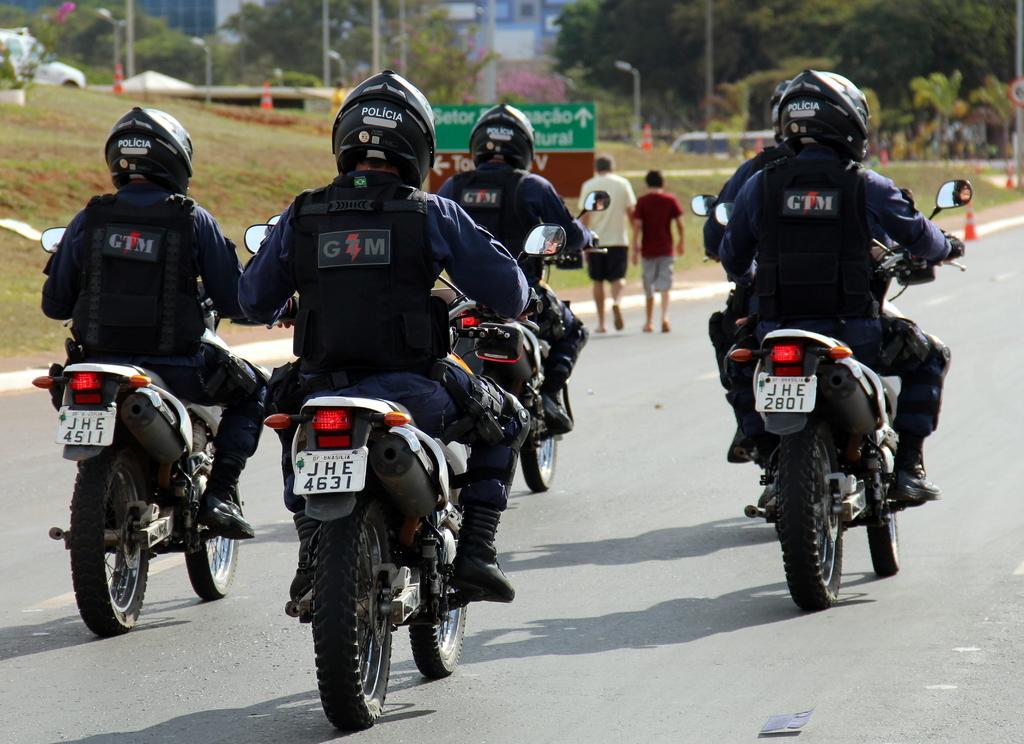In one or two sentences, can you explain what this image depicts? In this image, we can see persons wearing helmets and riding bikes on the road. There are two persons walking on the road. There are some poles and trees at the top of the image. There is a board beside the road. 